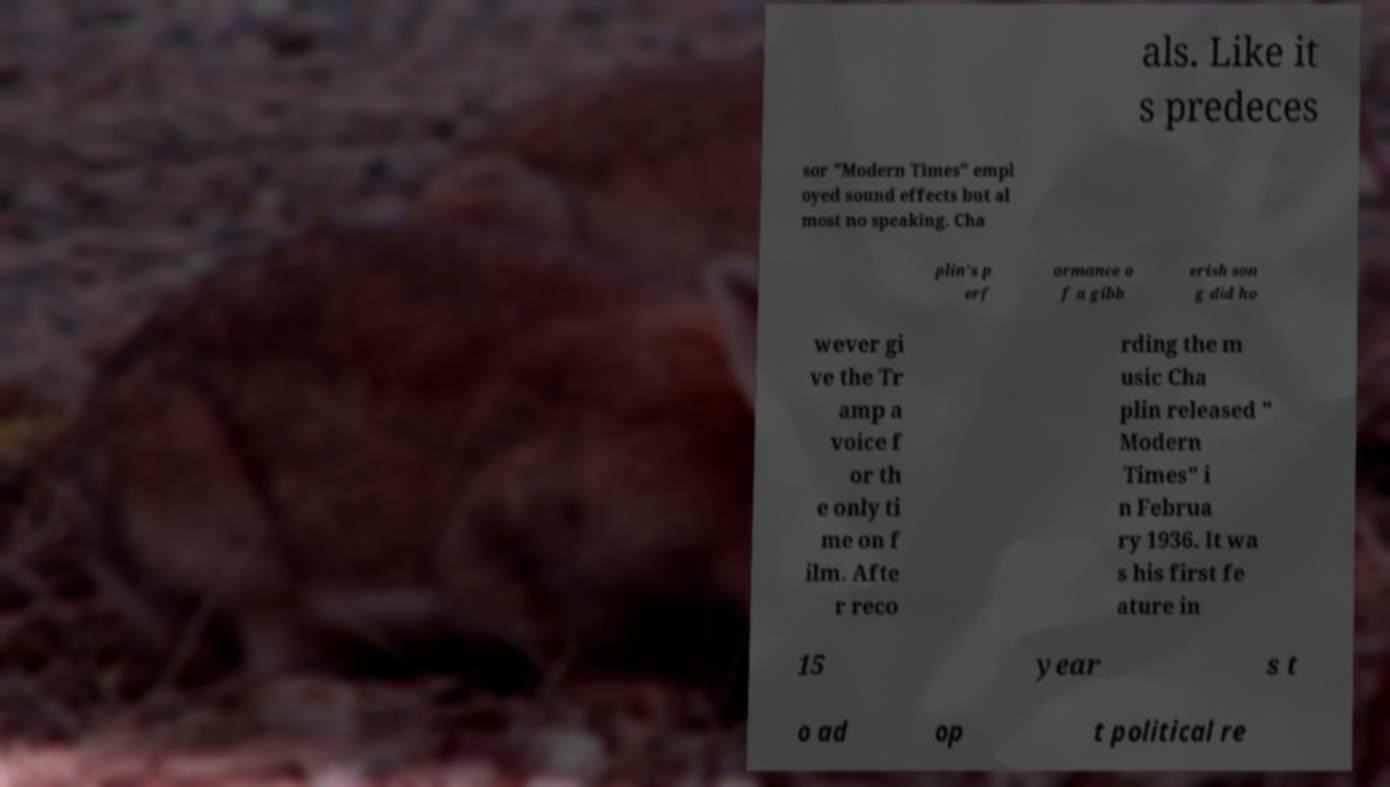For documentation purposes, I need the text within this image transcribed. Could you provide that? als. Like it s predeces sor "Modern Times" empl oyed sound effects but al most no speaking. Cha plin's p erf ormance o f a gibb erish son g did ho wever gi ve the Tr amp a voice f or th e only ti me on f ilm. Afte r reco rding the m usic Cha plin released " Modern Times" i n Februa ry 1936. It wa s his first fe ature in 15 year s t o ad op t political re 